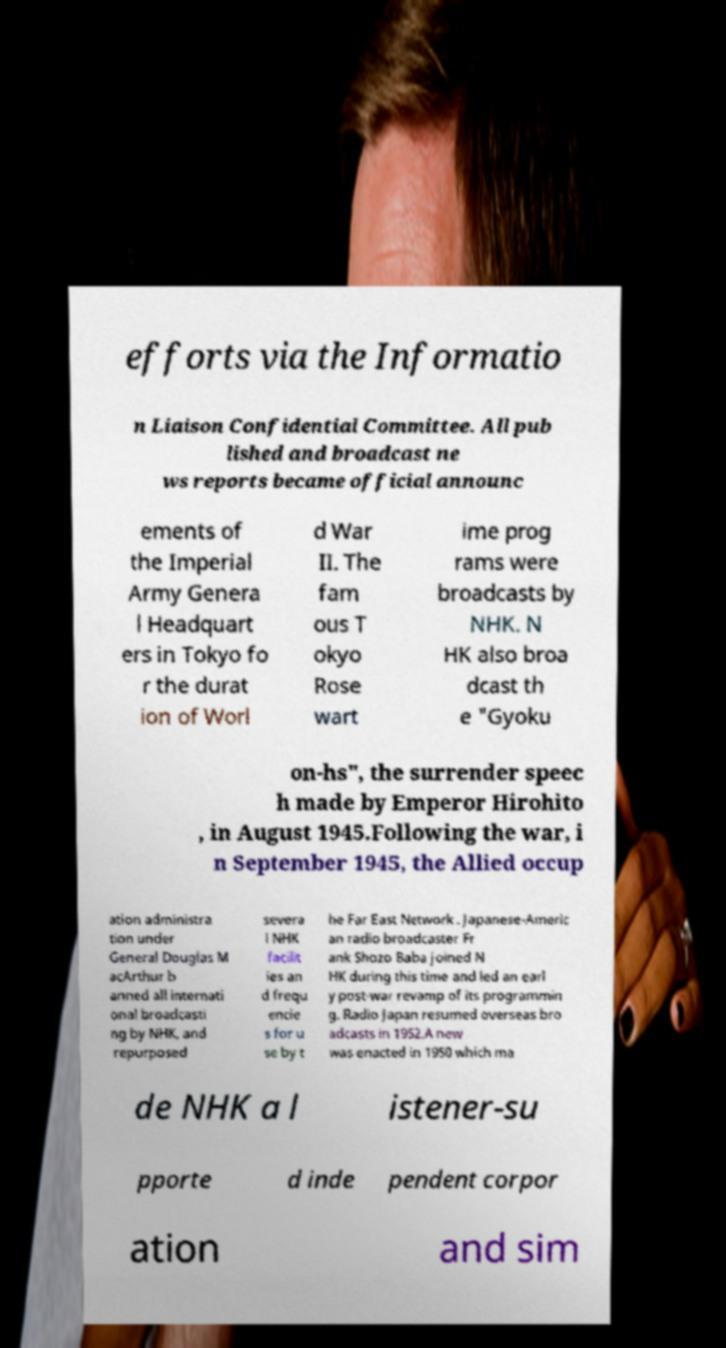There's text embedded in this image that I need extracted. Can you transcribe it verbatim? efforts via the Informatio n Liaison Confidential Committee. All pub lished and broadcast ne ws reports became official announc ements of the Imperial Army Genera l Headquart ers in Tokyo fo r the durat ion of Worl d War II. The fam ous T okyo Rose wart ime prog rams were broadcasts by NHK. N HK also broa dcast th e "Gyoku on-hs", the surrender speec h made by Emperor Hirohito , in August 1945.Following the war, i n September 1945, the Allied occup ation administra tion under General Douglas M acArthur b anned all internati onal broadcasti ng by NHK, and repurposed severa l NHK facilit ies an d frequ encie s for u se by t he Far East Network . Japanese-Americ an radio broadcaster Fr ank Shozo Baba joined N HK during this time and led an earl y post-war revamp of its programmin g. Radio Japan resumed overseas bro adcasts in 1952.A new was enacted in 1950 which ma de NHK a l istener-su pporte d inde pendent corpor ation and sim 